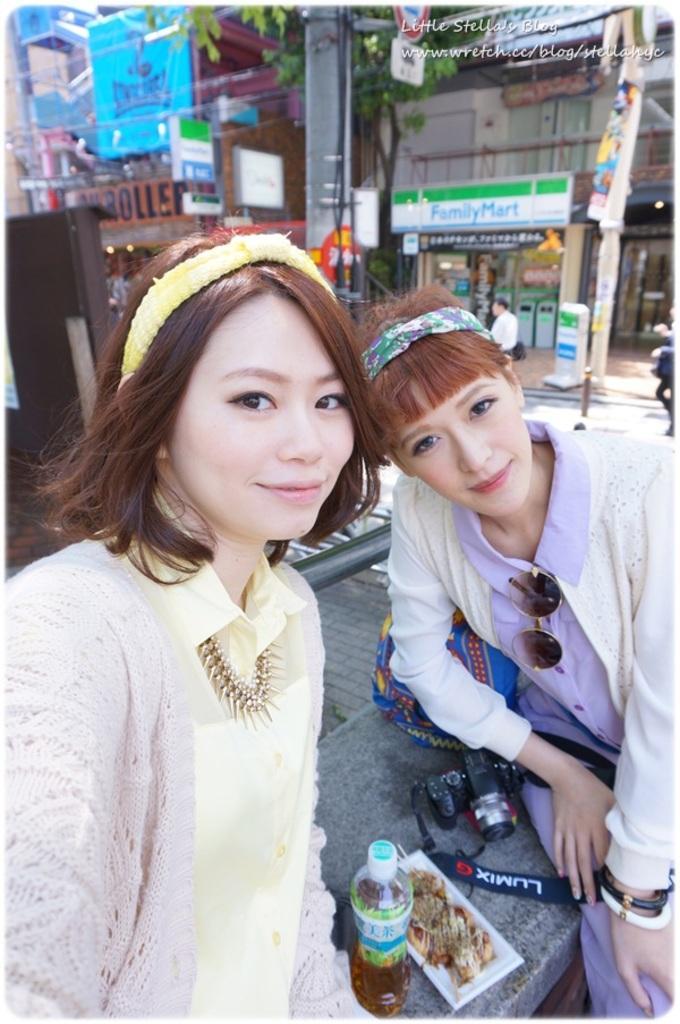Describe this image in one or two sentences. In the image we can see there are women sitting on the bench and there are food items kept in the plate. There is juice in the bottle and there is a camera kept on the bench. Behind there are buildings and there are street light poles. Background of the image is little blurred. 